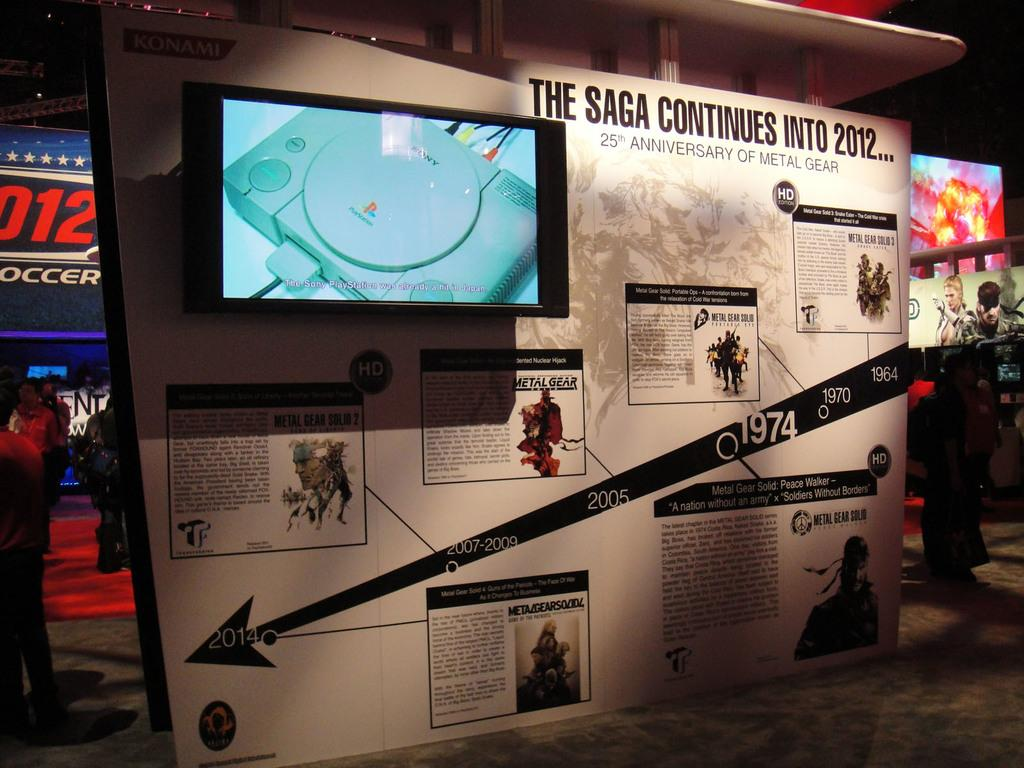<image>
Render a clear and concise summary of the photo. An informational display about a video game called Metal Gear. 